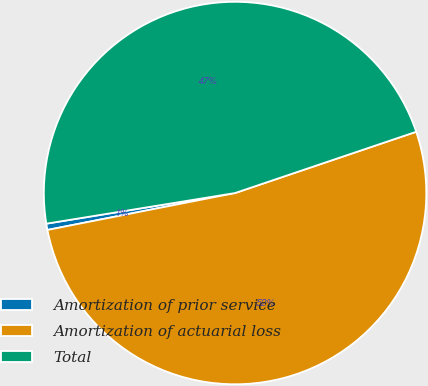<chart> <loc_0><loc_0><loc_500><loc_500><pie_chart><fcel>Amortization of prior service<fcel>Amortization of actuarial loss<fcel>Total<nl><fcel>0.53%<fcel>52.1%<fcel>47.37%<nl></chart> 